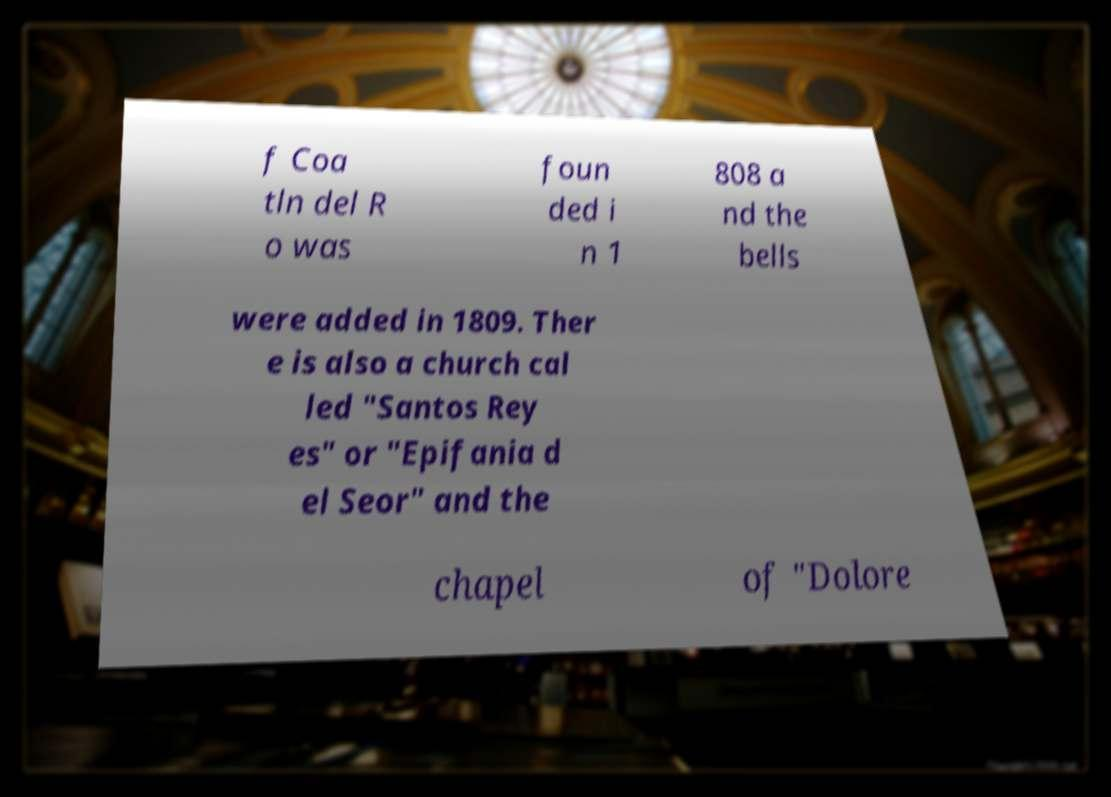Please read and relay the text visible in this image. What does it say? f Coa tln del R o was foun ded i n 1 808 a nd the bells were added in 1809. Ther e is also a church cal led "Santos Rey es" or "Epifania d el Seor" and the chapel of "Dolore 